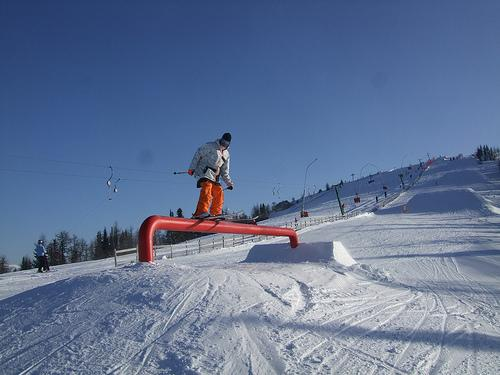Mention the notable colors and contrasts in the image. The image displays a bold contrast of colors, such as the vibrant orange pants worn by the skier against the cool, blue backdrop of the cloudless sky. Comment on the landscape and features present in the image. In the image, there is a ski slope with tracks, a wooden fence along the trail, a ski lift on wires, and a crystal-clear blue sky overhead. Describe the primary subject's clothing and equipment in the image. The main subject is wearing a black hat, grey coat, orange pants, and is equipped with white skis, while skiing down a slope near a rail. Identify the main subject's position and movement in the image. The athletic person is skiing along a trail, making ski tracks in the snow, and appears to be in motion towards the bottom of the slope. Provide a brief overview of the scene depicted in the image. An athletic man in orange pants is skiing down a slope, with a clear blue sky above, a wooden fence and ski lift nearby, and ski tracks in the snow. What is the overall theme or atmosphere of the image? The image displays a serene winter day filled with skiing activities, clear blue skies, and the peaceful surroundings of a ski slope. Describe the action or sport being performed in the image. The image depicts skiing, with an athletic individual skillfully sliding down a slope on white skis, leaving ski tracks in the fresh snow. Describe the weather and sky conditions in the picture. The weather in the image is sunny and clear, with a bright blue and cloudless sky providing a perfect backdrop for the skiing scene. Mention the key elements and the setting of the image. The image showcases an athletic skier, wearing orange pants and a grey coat, skiing near a wooden fence and a ski lift, under a cloudless blue sky. Summarize the scene taking place in the picture. The scene features a skier enjoying a run down a slope, leaving behind ski tracks, with a beautiful blue sky, wooden fence, and ski lift in the background. 